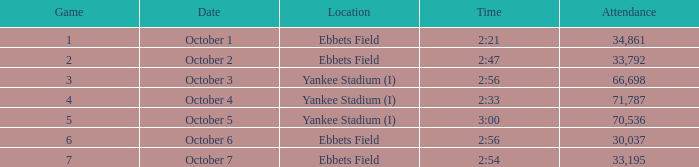Yankee stadium (i), and a duration of 3:00 has what number of attendees for this venue? 70536.0. Would you be able to parse every entry in this table? {'header': ['Game', 'Date', 'Location', 'Time', 'Attendance'], 'rows': [['1', 'October 1', 'Ebbets Field', '2:21', '34,861'], ['2', 'October 2', 'Ebbets Field', '2:47', '33,792'], ['3', 'October 3', 'Yankee Stadium (I)', '2:56', '66,698'], ['4', 'October 4', 'Yankee Stadium (I)', '2:33', '71,787'], ['5', 'October 5', 'Yankee Stadium (I)', '3:00', '70,536'], ['6', 'October 6', 'Ebbets Field', '2:56', '30,037'], ['7', 'October 7', 'Ebbets Field', '2:54', '33,195']]} 